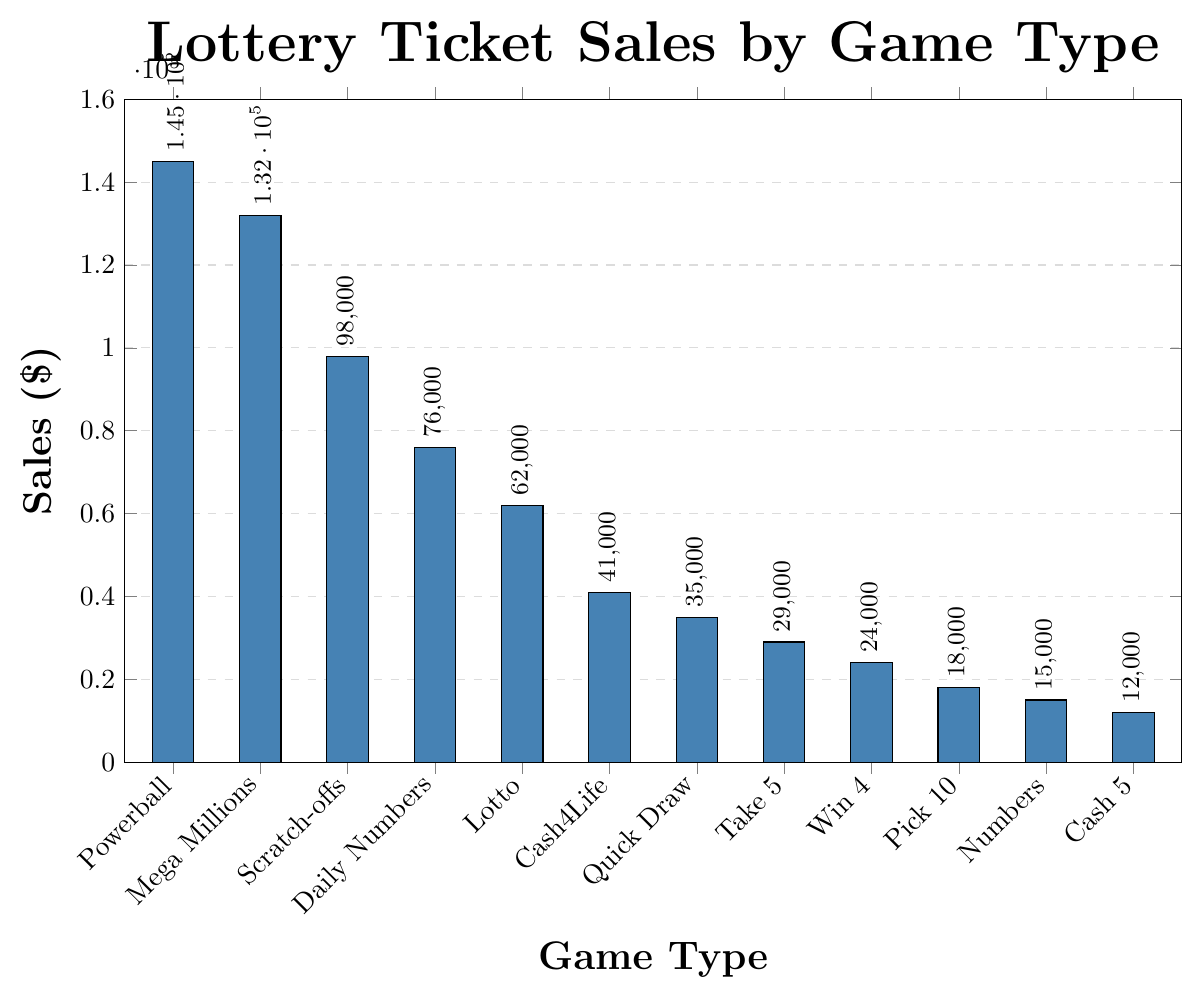Which game type has the highest sales? By observing the bar heights, we can see that Powerball has the tallest bar, indicating the highest sales.
Answer: Powerball Which game type has the lowest sales? The shortest bar in the chart corresponds to Cash 5, indicating it has the lowest sales.
Answer: Cash 5 What is the total sales for Mega Millions and Scratch-offs combined? Add the sales of Mega Millions ($132,000) to the sales of Scratch-offs ($98,000): $132,000 + $98,000 = $230,000.
Answer: $230,000 Which games have sales greater than $100,000? By looking at the bar heights, Powerball ($145,000) and Mega Millions ($132,000) have sales greater than $100,000.
Answer: Powerball and Mega Millions How much higher are Powerball sales compared to Daily Numbers sales? Subtract the sales of Daily Numbers ($76,000) from the sales of Powerball ($145,000): $145,000 - $76,000 = $69,000.
Answer: $69,000 What is the mean sales value for all the games? Sum all sales values: $145,000 + $132,000 + $98,000 + $76,000 + $62,000 + $41,000 + $35,000 + $29,000 + $24,000 + $18,000 + $15,000 + $12,000 = $687,000. Divide by the number of games (12): $687,000 / 12 ≈ $57,250.
Answer: $57,250 Which two consecutive game types have the smallest difference in their sales? Calculate differences between consecutive entries: Mega Millions and Scratch-offs ($132,000 - $98,000 = $34,000), then Scratch-offs and Daily Numbers ($98,000 - $76,000 = $22,000). Continue, find the smallest is Pick 10 and Numbers ($18,000 - $15,000 = $3,000).
Answer: Pick 10 and Numbers How do the sales of Quick Draw compare to Lotto? By observing the bar heights, Lotto sales ($62,000) are higher than Quick Draw sales ($35,000).
Answer: Lotto is higher What is the combined sales for all games with sales less than $50,000? Add all relevant sales: Cash4Life ($41,000) + Quick Draw ($35,000) + Take 5 ($29,000) + Win 4 ($24,000) + Pick 10 ($18,000) + Numbers ($15,000) + Cash 5 ($12,000). Total: $41,000 + $35,000 + $29,000 + $24,000 + $18,000 + $15,000 + $12,000 = $174,000.
Answer: $174,000 Which game had sales closest to the median value? List sales in order: 12k, 15k, 18k, 24k, 29k, 35k, 41k, 62k, 76k, 98k, 132k, 145k. Median location (12+1)/2 = 6.5 -> (35k+41k)/2 = 38k. Closest is Quick Draw ($35k).
Answer: Quick Draw 